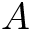<formula> <loc_0><loc_0><loc_500><loc_500>A</formula> 